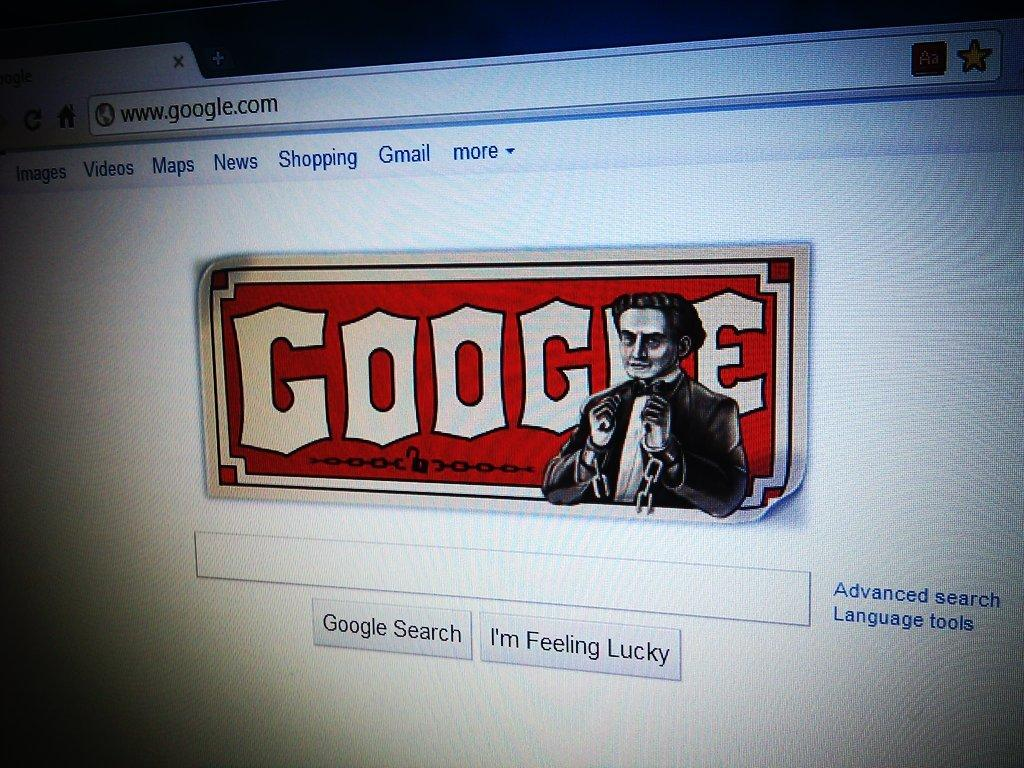<image>
Offer a succinct explanation of the picture presented. A Google search page with Harry Houdini's picture. 